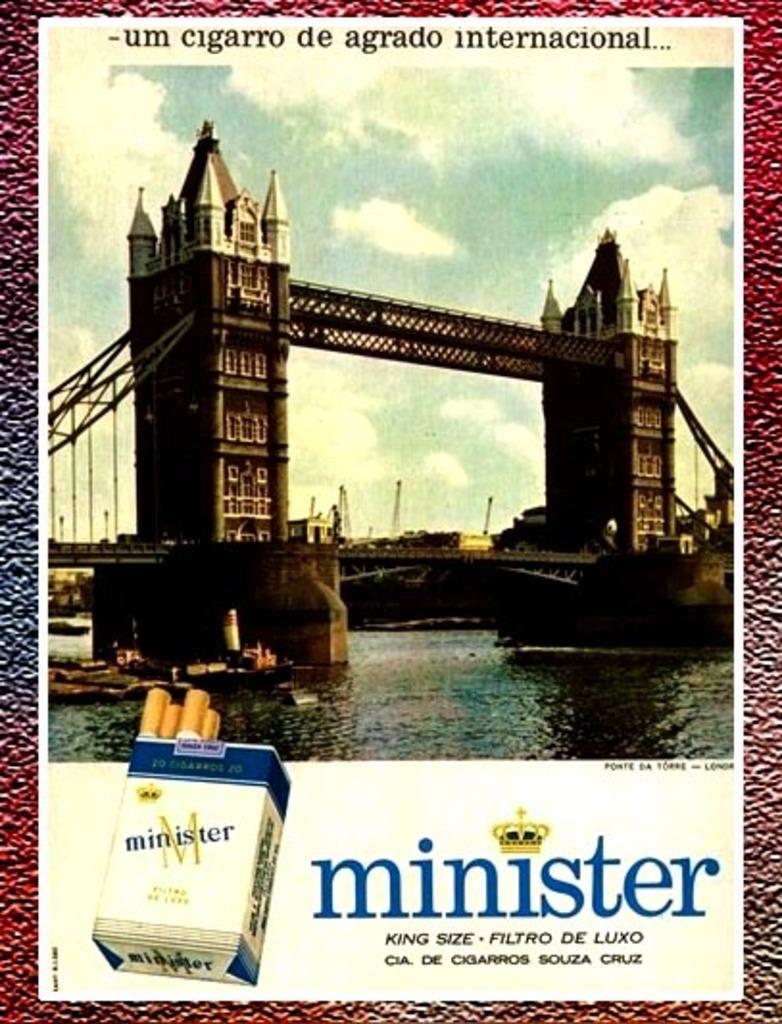<image>
Present a compact description of the photo's key features. The London bridge being featured in an advertisement for Minister brand cigarettes. 